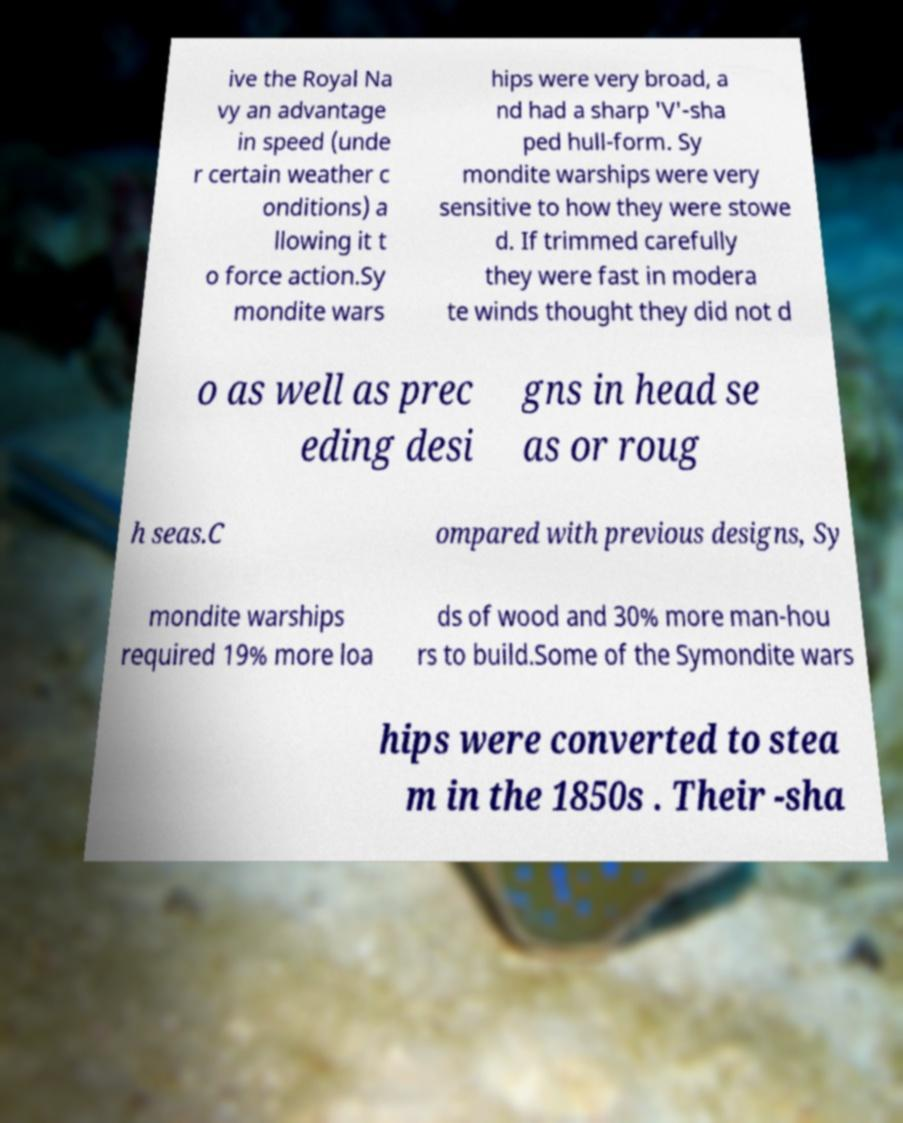For documentation purposes, I need the text within this image transcribed. Could you provide that? ive the Royal Na vy an advantage in speed (unde r certain weather c onditions) a llowing it t o force action.Sy mondite wars hips were very broad, a nd had a sharp 'V'-sha ped hull-form. Sy mondite warships were very sensitive to how they were stowe d. If trimmed carefully they were fast in modera te winds thought they did not d o as well as prec eding desi gns in head se as or roug h seas.C ompared with previous designs, Sy mondite warships required 19% more loa ds of wood and 30% more man-hou rs to build.Some of the Symondite wars hips were converted to stea m in the 1850s . Their -sha 